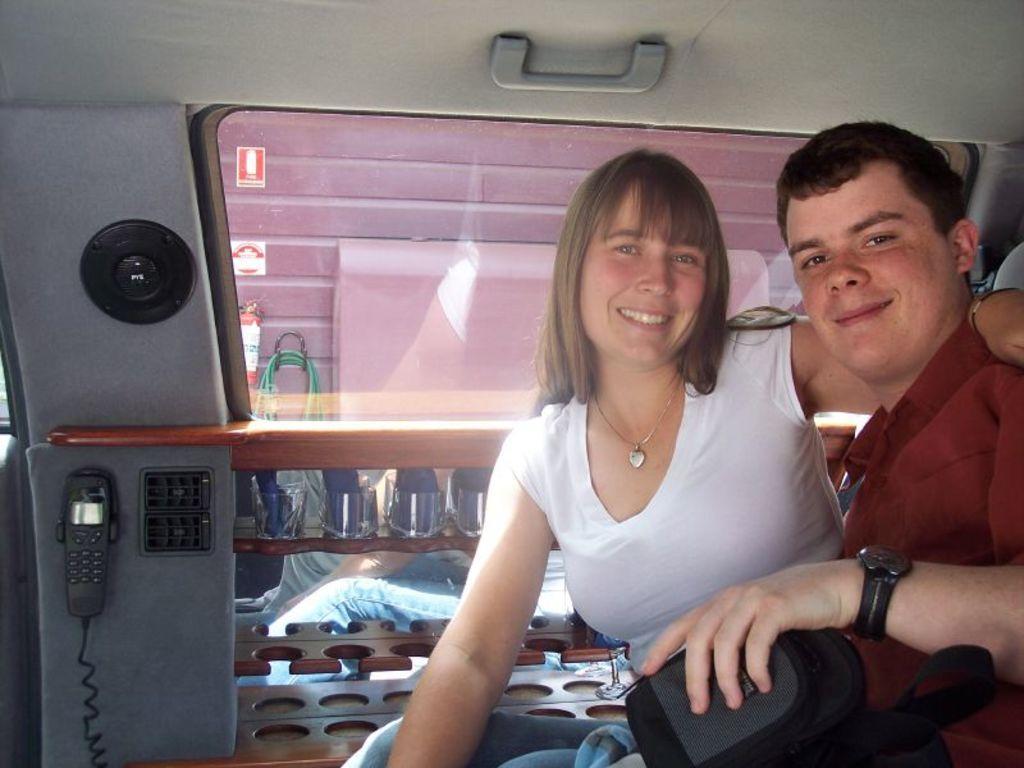In one or two sentences, can you explain what this image depicts? In this picture we can see there are two people sitting and smiling. Behind the people there is a telephone, speak, glass window and a handle. 